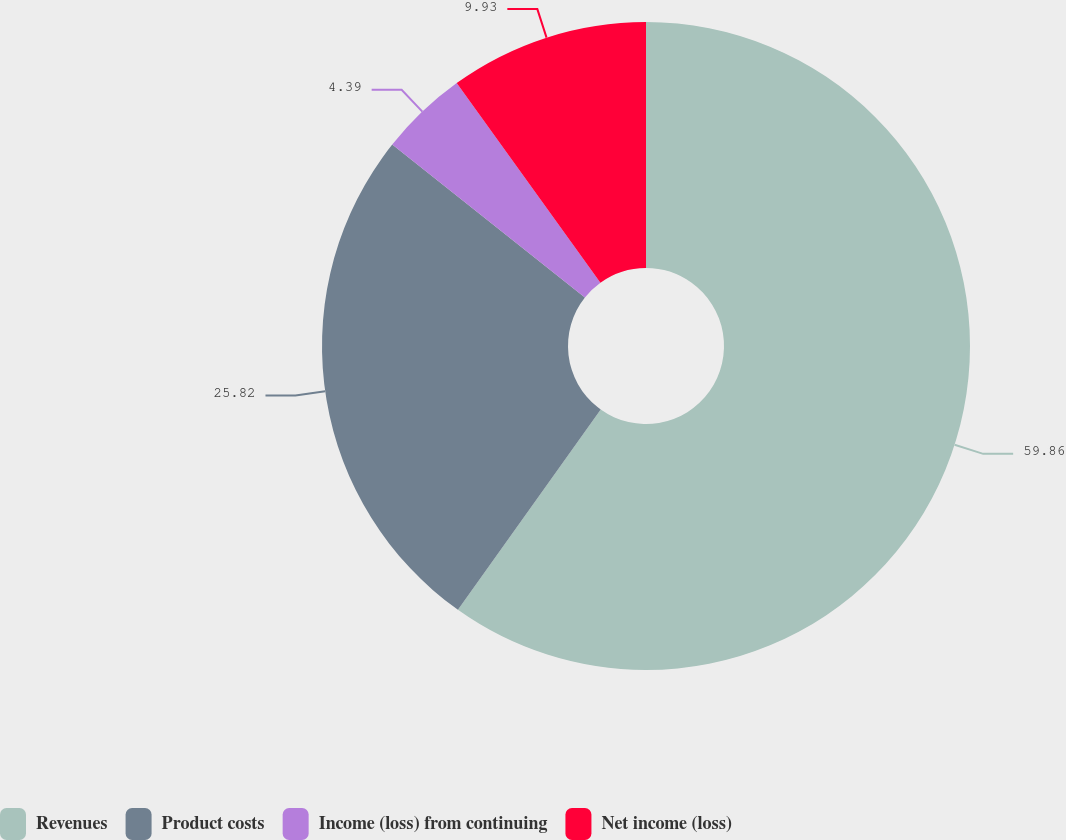<chart> <loc_0><loc_0><loc_500><loc_500><pie_chart><fcel>Revenues<fcel>Product costs<fcel>Income (loss) from continuing<fcel>Net income (loss)<nl><fcel>59.85%<fcel>25.82%<fcel>4.39%<fcel>9.93%<nl></chart> 